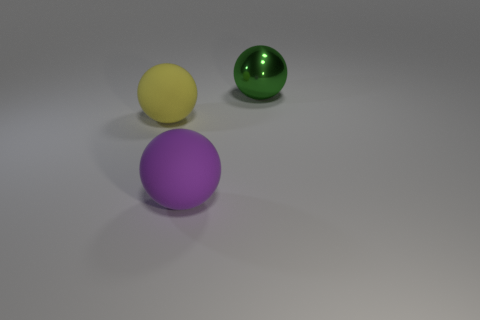Are there any distinctive features or textures on the objects that stand out? Yes, the green sphere has a reflective surface that stands out due to its shininess, which contrasts with the matte textures of the yellow and purple spheres. 